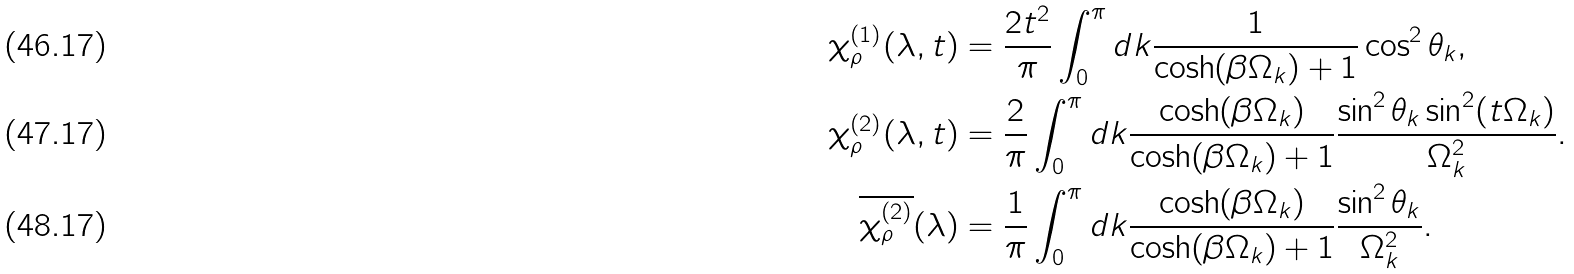<formula> <loc_0><loc_0><loc_500><loc_500>\chi _ { \rho } ^ { ( 1 ) } ( \lambda , t ) & = \frac { 2 t ^ { 2 } } { \pi } \int _ { 0 } ^ { \pi } d k \frac { 1 } { \cosh ( \beta \Omega _ { k } ) + 1 } \cos ^ { 2 } \theta _ { k } , \\ \chi _ { \rho } ^ { ( 2 ) } ( \lambda , t ) & = \frac { 2 } { \pi } \int _ { 0 } ^ { \pi } d k \frac { \cosh ( \beta \Omega _ { k } ) } { \cosh ( \beta \Omega _ { k } ) + 1 } \frac { \sin ^ { 2 } \theta _ { k } \sin ^ { 2 } ( t \Omega _ { k } ) } { \Omega _ { k } ^ { 2 } } . \\ \overline { \chi _ { \rho } ^ { ( 2 ) } } ( \lambda ) & = \frac { 1 } { \pi } \int _ { 0 } ^ { \pi } d k \frac { \cosh ( \beta \Omega _ { k } ) } { \cosh ( \beta \Omega _ { k } ) + 1 } \frac { \sin ^ { 2 } \theta _ { k } } { \Omega _ { k } ^ { 2 } } .</formula> 